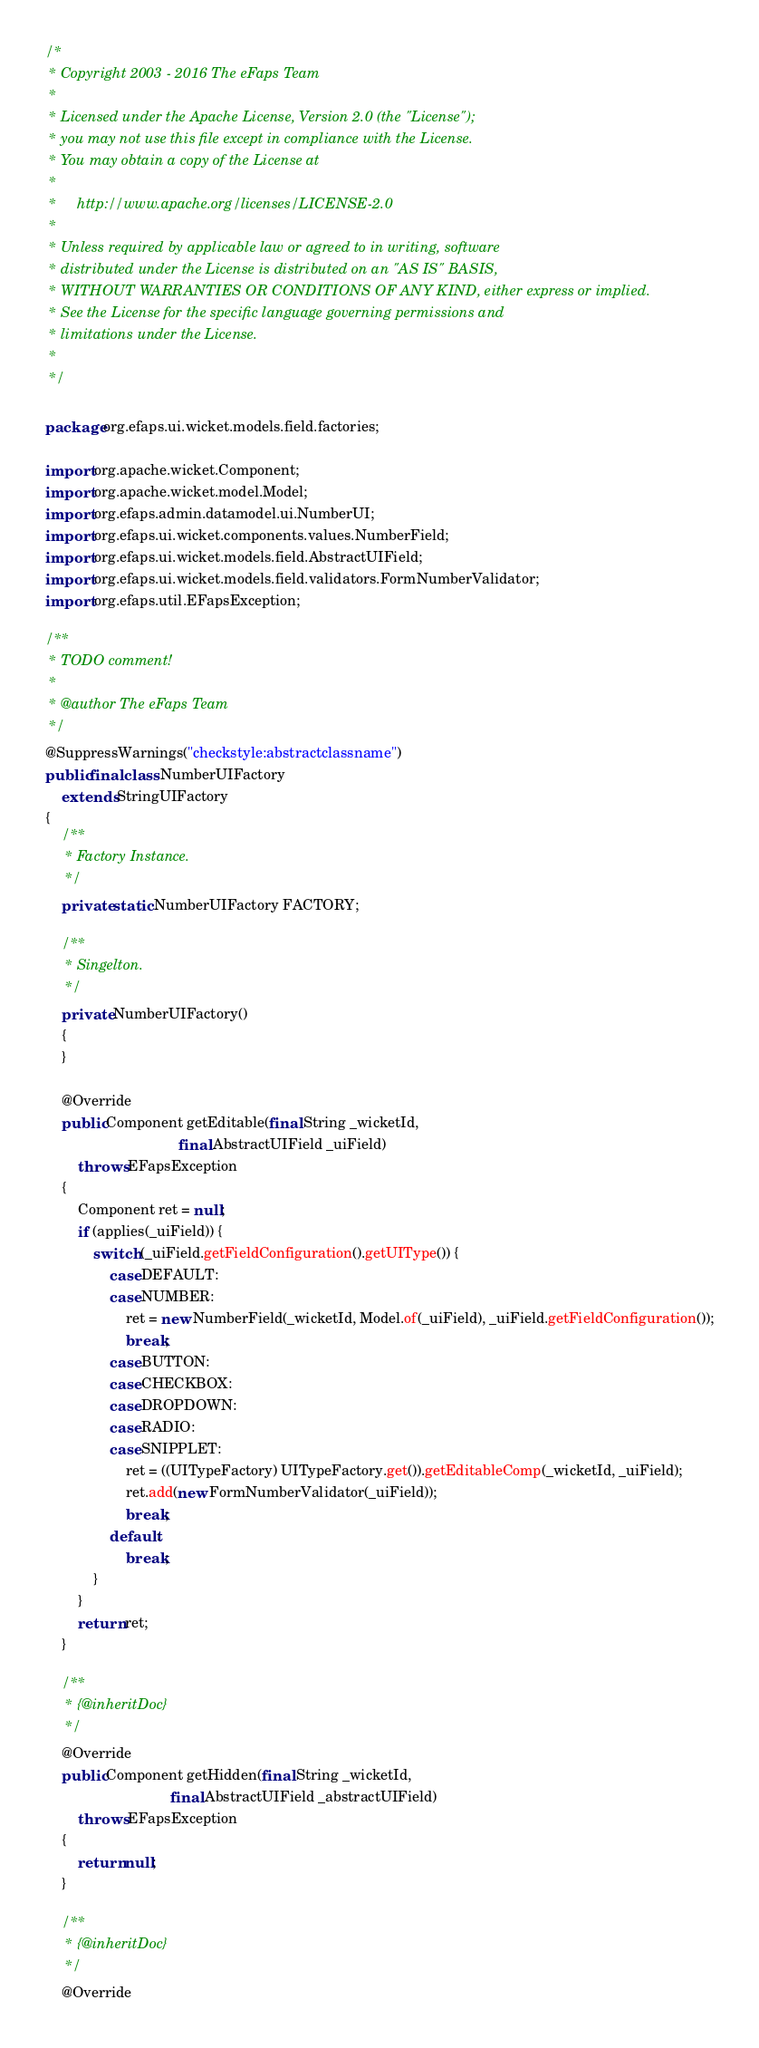<code> <loc_0><loc_0><loc_500><loc_500><_Java_>/*
 * Copyright 2003 - 2016 The eFaps Team
 *
 * Licensed under the Apache License, Version 2.0 (the "License");
 * you may not use this file except in compliance with the License.
 * You may obtain a copy of the License at
 *
 *     http://www.apache.org/licenses/LICENSE-2.0
 *
 * Unless required by applicable law or agreed to in writing, software
 * distributed under the License is distributed on an "AS IS" BASIS,
 * WITHOUT WARRANTIES OR CONDITIONS OF ANY KIND, either express or implied.
 * See the License for the specific language governing permissions and
 * limitations under the License.
 *
 */

package org.efaps.ui.wicket.models.field.factories;

import org.apache.wicket.Component;
import org.apache.wicket.model.Model;
import org.efaps.admin.datamodel.ui.NumberUI;
import org.efaps.ui.wicket.components.values.NumberField;
import org.efaps.ui.wicket.models.field.AbstractUIField;
import org.efaps.ui.wicket.models.field.validators.FormNumberValidator;
import org.efaps.util.EFapsException;

/**
 * TODO comment!
 *
 * @author The eFaps Team
 */
@SuppressWarnings("checkstyle:abstractclassname")
public final class NumberUIFactory
    extends StringUIFactory
{
    /**
     * Factory Instance.
     */
    private static NumberUIFactory FACTORY;

    /**
     * Singelton.
     */
    private NumberUIFactory()
    {
    }

    @Override
    public Component getEditable(final String _wicketId,
                                 final AbstractUIField _uiField)
        throws EFapsException
    {
        Component ret = null;
        if (applies(_uiField)) {
            switch (_uiField.getFieldConfiguration().getUIType()) {
                case DEFAULT:
                case NUMBER:
                    ret = new NumberField(_wicketId, Model.of(_uiField), _uiField.getFieldConfiguration());
                    break;
                case BUTTON:
                case CHECKBOX:
                case DROPDOWN:
                case RADIO:
                case SNIPPLET:
                    ret = ((UITypeFactory) UITypeFactory.get()).getEditableComp(_wicketId, _uiField);
                    ret.add(new FormNumberValidator(_uiField));
                    break;
                default:
                    break;
            }
        }
        return ret;
    }

    /**
     * {@inheritDoc}
     */
    @Override
    public Component getHidden(final String _wicketId,
                               final AbstractUIField _abstractUIField)
        throws EFapsException
    {
        return null;
    }

    /**
     * {@inheritDoc}
     */
    @Override</code> 